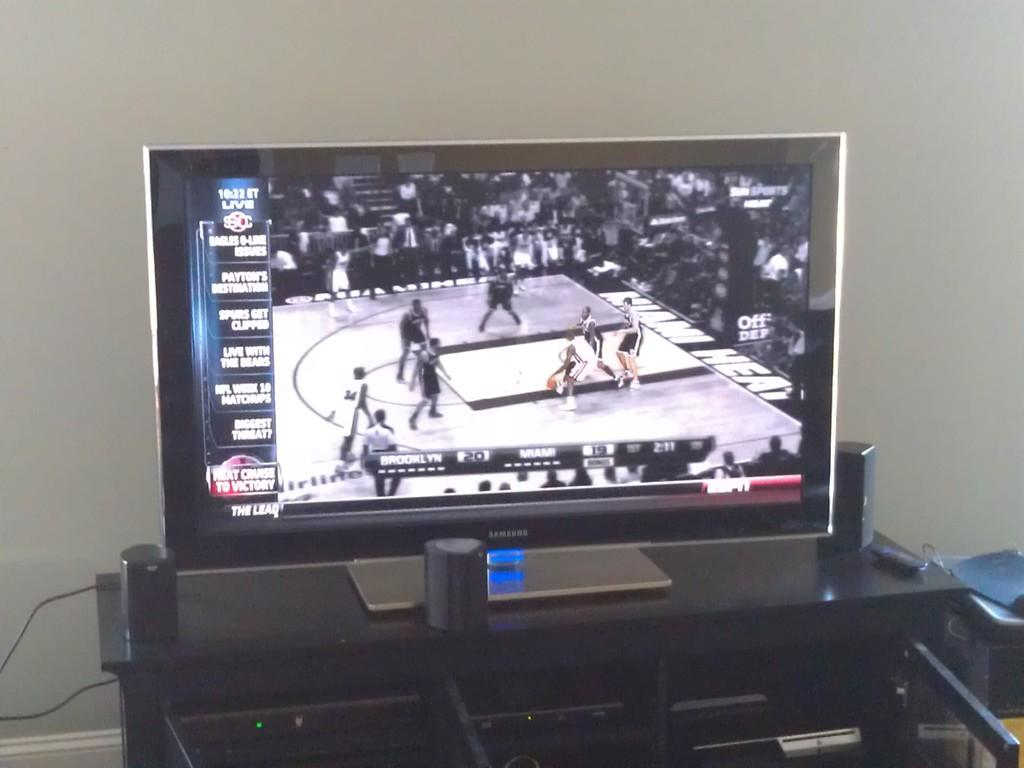<image>
Create a compact narrative representing the image presented. a Sportscenter live ad on a television set 